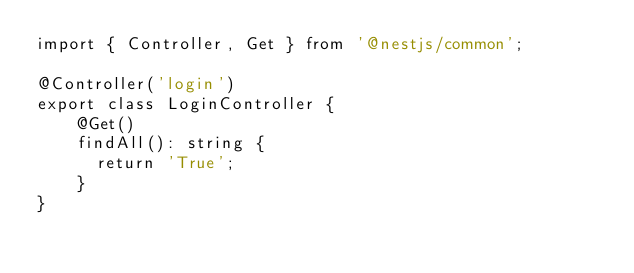<code> <loc_0><loc_0><loc_500><loc_500><_TypeScript_>import { Controller, Get } from '@nestjs/common';

@Controller('login')
export class LoginController {
    @Get()
    findAll(): string {
      return 'True';
    }
}
</code> 